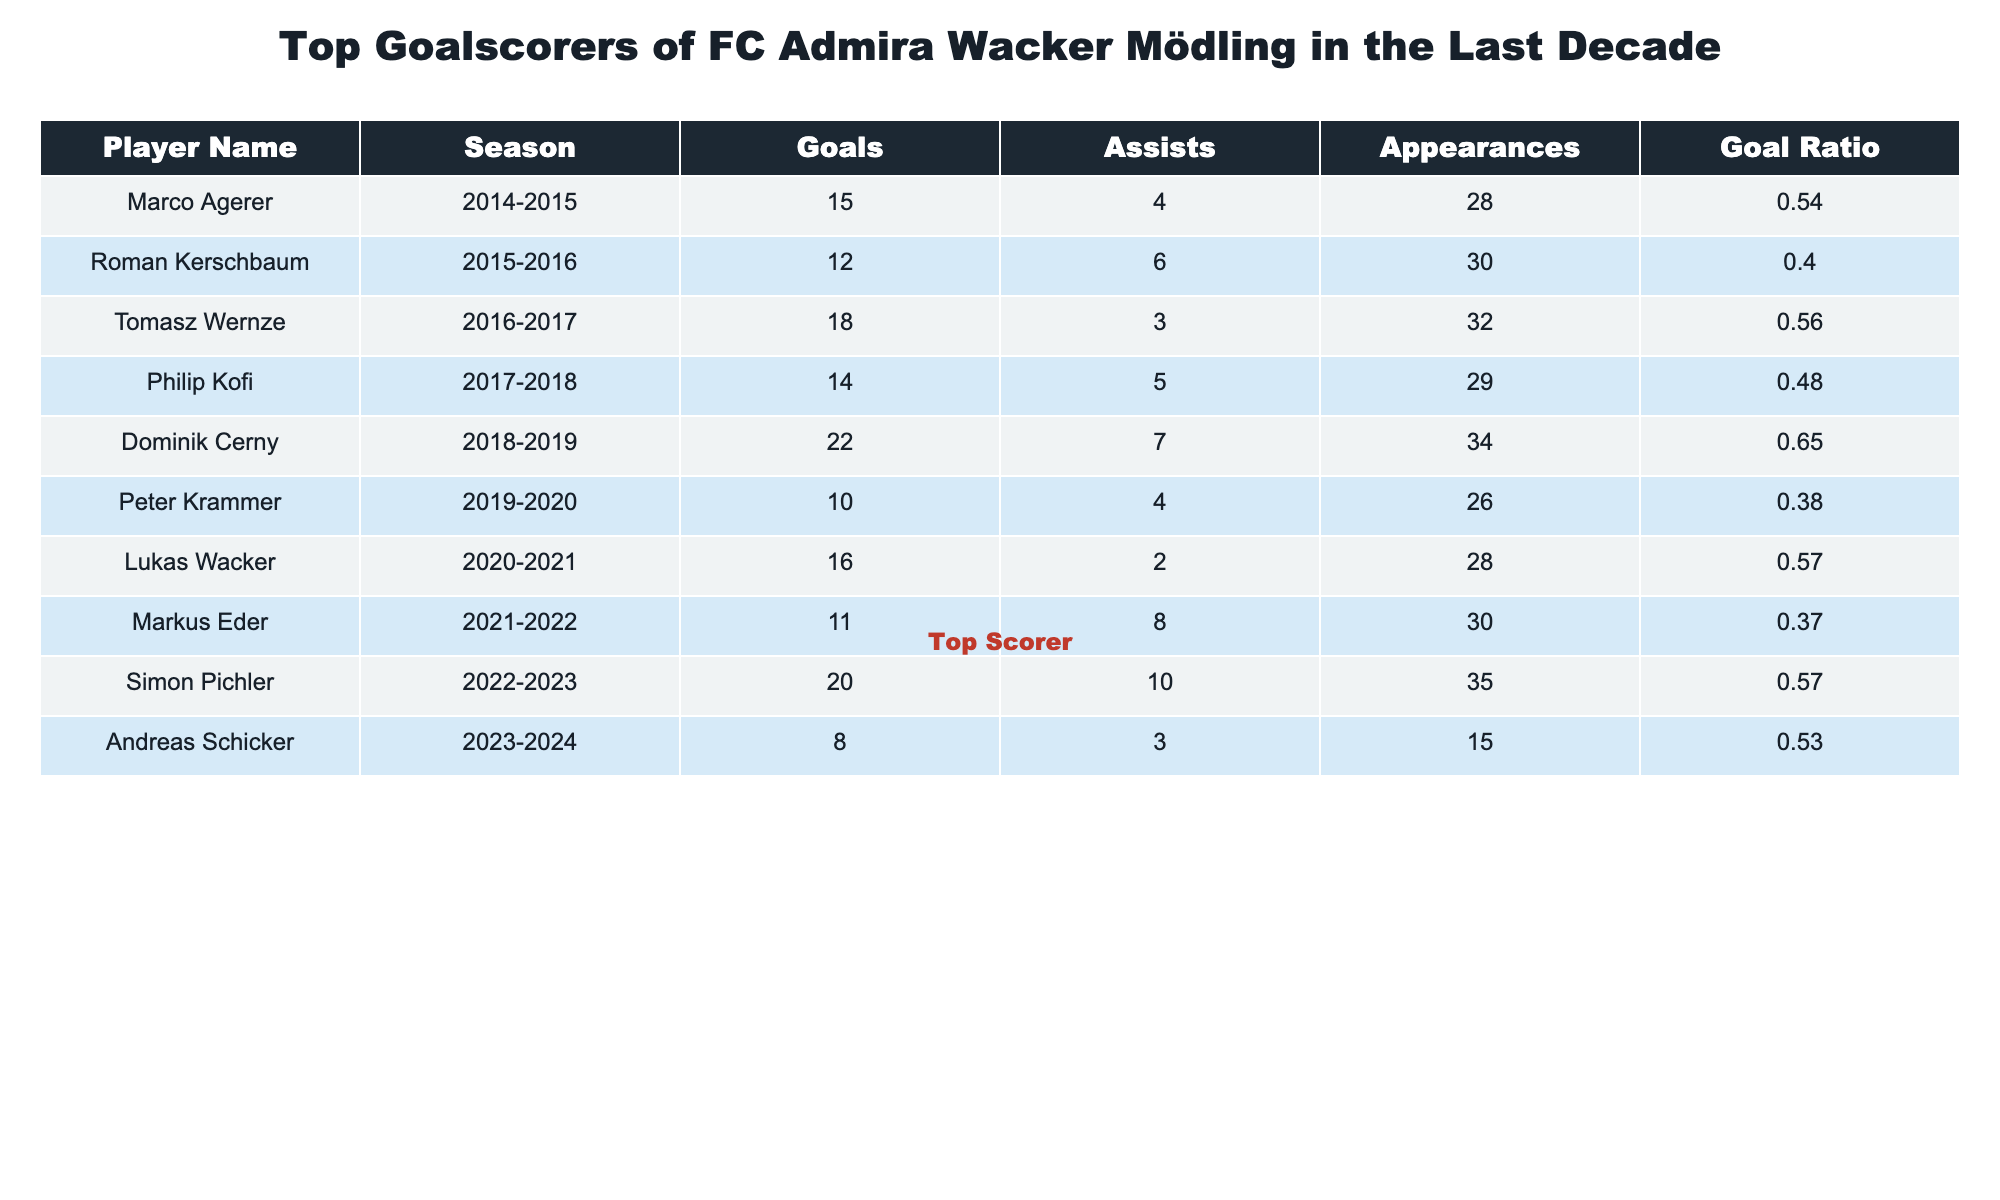What is the name of the top goalscorer for FC Admira Wacker Mödling in the last decade? The table indicates that the player with the highest number of goals is Dominik Cerny with 22 goals during the 2018-2019 season.
Answer: Dominik Cerny How many goals did Roman Kerschbaum score? By looking at the entry for Roman Kerschbaum in the table, it shows he scored 12 goals during the 2015-2016 season.
Answer: 12 Which player had the highest goal ratio? To find the highest goal ratio, I compare the 'Goal Ratio' column. Dominik Cerny's ratio of 0.65 is the highest among all players listed.
Answer: Dominik Cerny How many total goals were scored by the players listed in the table? I sum the goals in the 'Goals' column: 15 + 12 + 18 + 14 + 22 + 10 + 16 + 11 + 20 + 8 =  156 total goals.
Answer: 156 Did Simon Pichler have more assists than Marco Agerer? I check the 'Assists' column for both players: Simon Pichler had 10 assists while Marco Agerer had 4 assists. Since 10 is greater than 4, the answer is yes.
Answer: Yes What is the average number of goals per season for players who scored more than 15 goals? First, I identify the players who scored more than 15 goals: Dominik Cerny (22), Tomasz Wernze (18), and Simon Pichler (20). Their total goals are 22 + 18 + 20 = 60. This occurred over 3 seasons, so I divide 60 by 3: 60/3 = 20.
Answer: 20 Which season had the fewest total goals scored by a player? I look at the 'Goals' column to find the minimum value, which is 8 goals scored by Andreas Schicker in the 2023-2024 season.
Answer: 2023-2024 If we consider only the seasons with at least 30 appearances, what is the average number of goals scored by those players? I first check the appearances for each player, noting that Dominik Cerny, Tomasz Wernze, Simon Pichler, and Marco Agerer all had at least 30 appearances. Their goals are 22, 18, 20, and 15. Summing these gives 75 goals across 4 players (75/4 = 18.75). Thus, the average is approximately 19.
Answer: 19 Did any player have more assists than goals in the given seasons? I review the 'Goals' and 'Assists' columns for each player. Markus Eder had 11 goals and 8 assists. This remains true as all others either have equal or more goals than assists. Hence, the answer is no.
Answer: No 